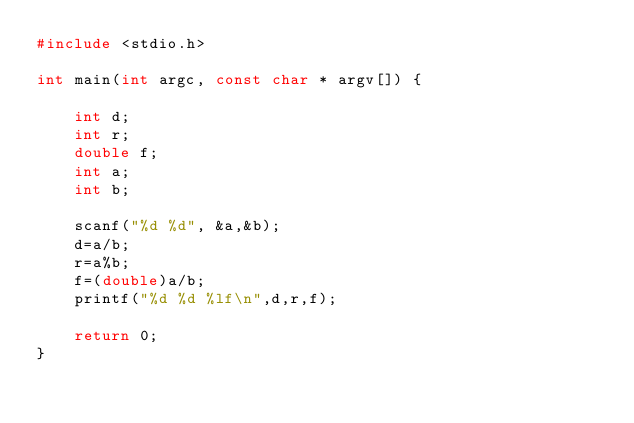<code> <loc_0><loc_0><loc_500><loc_500><_C_>#include <stdio.h>

int main(int argc, const char * argv[]) {

    int d;
    int r;
    double f;
    int a;
    int b;
    
    scanf("%d %d", &a,&b);
    d=a/b;
    r=a%b;
    f=(double)a/b;
    printf("%d %d %lf\n",d,r,f);
    
    return 0;
}</code> 